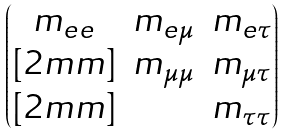Convert formula to latex. <formula><loc_0><loc_0><loc_500><loc_500>\begin{pmatrix} m _ { e e } & m _ { e \mu } & m _ { e \tau } \\ [ 2 m m ] & m _ { \mu \mu } & m _ { \mu \tau } \\ [ 2 m m ] & & m _ { \tau \tau } \end{pmatrix}</formula> 